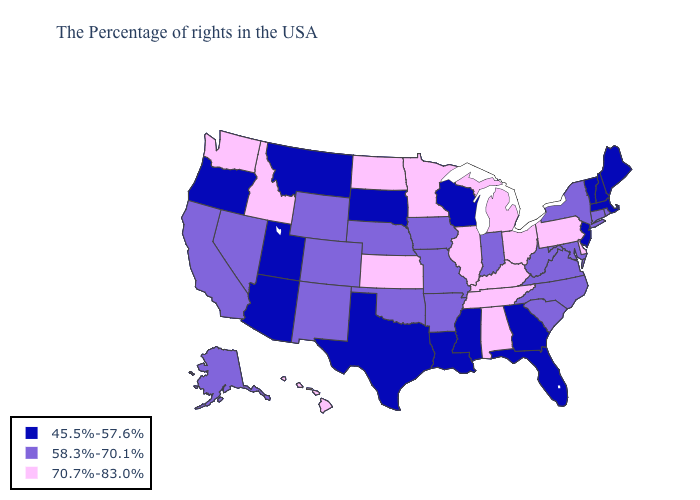Name the states that have a value in the range 58.3%-70.1%?
Give a very brief answer. Rhode Island, Connecticut, New York, Maryland, Virginia, North Carolina, South Carolina, West Virginia, Indiana, Missouri, Arkansas, Iowa, Nebraska, Oklahoma, Wyoming, Colorado, New Mexico, Nevada, California, Alaska. What is the value of Nebraska?
Short answer required. 58.3%-70.1%. Name the states that have a value in the range 45.5%-57.6%?
Give a very brief answer. Maine, Massachusetts, New Hampshire, Vermont, New Jersey, Florida, Georgia, Wisconsin, Mississippi, Louisiana, Texas, South Dakota, Utah, Montana, Arizona, Oregon. Does Wisconsin have the highest value in the MidWest?
Concise answer only. No. Name the states that have a value in the range 58.3%-70.1%?
Short answer required. Rhode Island, Connecticut, New York, Maryland, Virginia, North Carolina, South Carolina, West Virginia, Indiana, Missouri, Arkansas, Iowa, Nebraska, Oklahoma, Wyoming, Colorado, New Mexico, Nevada, California, Alaska. Does Connecticut have the highest value in the Northeast?
Keep it brief. No. Does Delaware have a higher value than Montana?
Short answer required. Yes. Name the states that have a value in the range 58.3%-70.1%?
Short answer required. Rhode Island, Connecticut, New York, Maryland, Virginia, North Carolina, South Carolina, West Virginia, Indiana, Missouri, Arkansas, Iowa, Nebraska, Oklahoma, Wyoming, Colorado, New Mexico, Nevada, California, Alaska. Does the map have missing data?
Quick response, please. No. What is the lowest value in states that border New Mexico?
Be succinct. 45.5%-57.6%. What is the value of Arizona?
Keep it brief. 45.5%-57.6%. What is the value of Vermont?
Quick response, please. 45.5%-57.6%. Does New Mexico have the same value as Maryland?
Be succinct. Yes. 